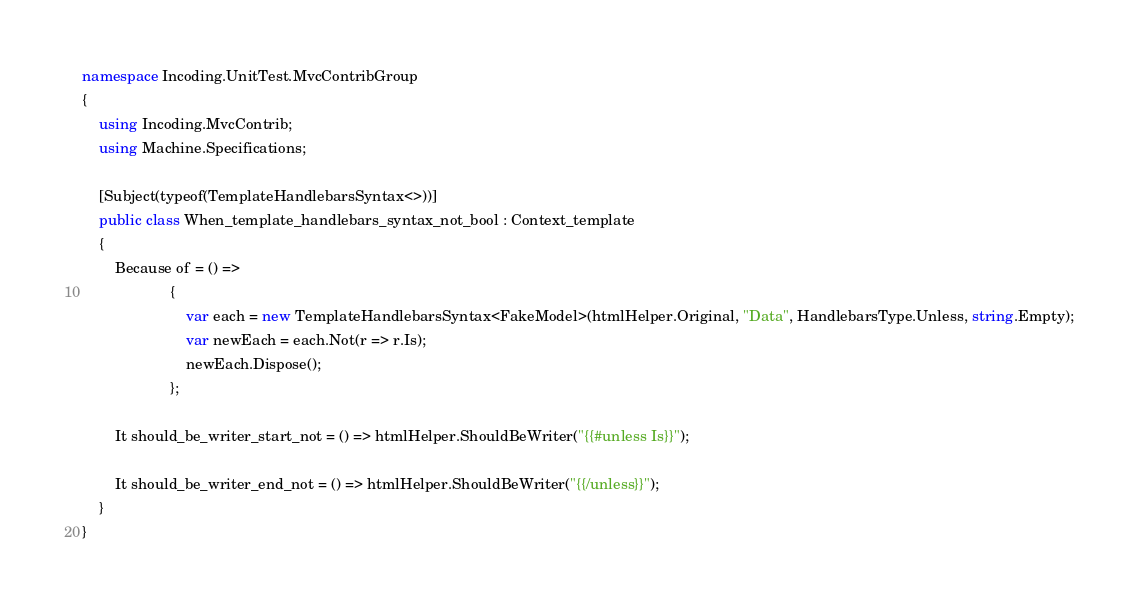<code> <loc_0><loc_0><loc_500><loc_500><_C#_>namespace Incoding.UnitTest.MvcContribGroup
{
    using Incoding.MvcContrib;
    using Machine.Specifications;

    [Subject(typeof(TemplateHandlebarsSyntax<>))]
    public class When_template_handlebars_syntax_not_bool : Context_template
    {
        Because of = () =>
                     {
                         var each = new TemplateHandlebarsSyntax<FakeModel>(htmlHelper.Original, "Data", HandlebarsType.Unless, string.Empty);
                         var newEach = each.Not(r => r.Is);
                         newEach.Dispose();
                     };

        It should_be_writer_start_not = () => htmlHelper.ShouldBeWriter("{{#unless Is}}");

        It should_be_writer_end_not = () => htmlHelper.ShouldBeWriter("{{/unless}}");
    }
}</code> 